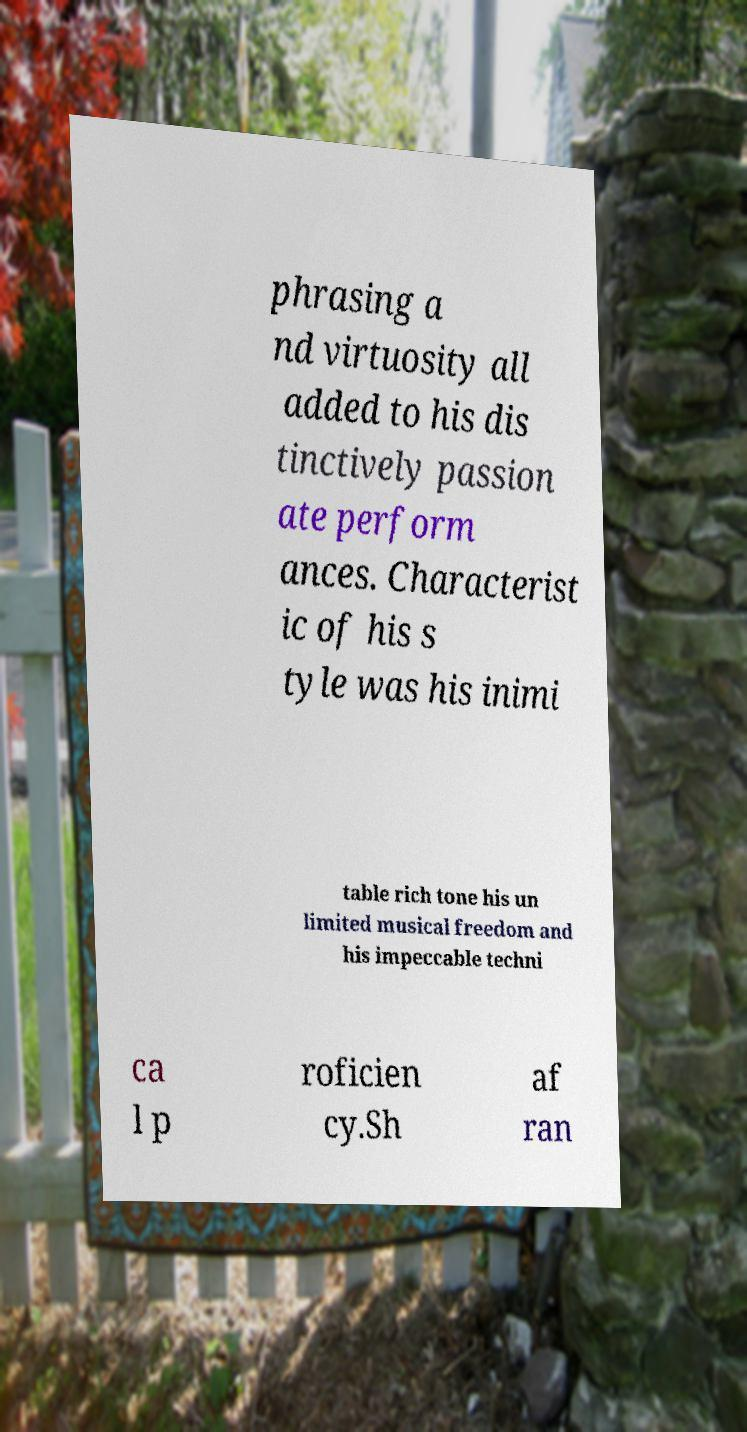What messages or text are displayed in this image? I need them in a readable, typed format. phrasing a nd virtuosity all added to his dis tinctively passion ate perform ances. Characterist ic of his s tyle was his inimi table rich tone his un limited musical freedom and his impeccable techni ca l p roficien cy.Sh af ran 